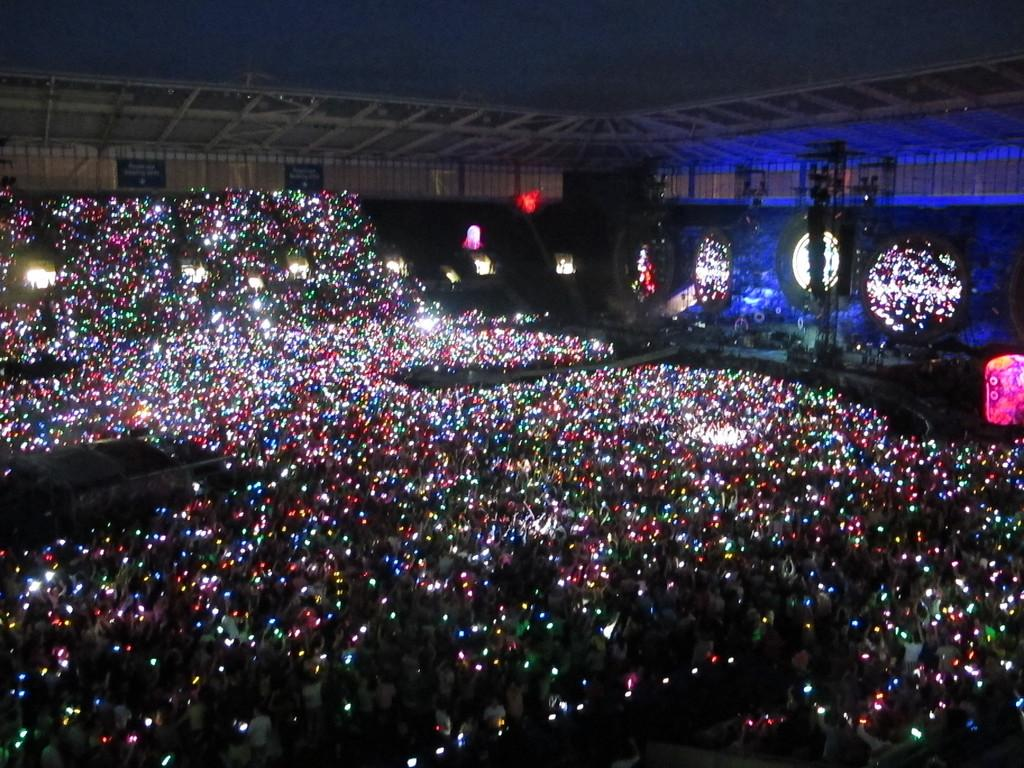How many people are present in the image? There are many people in the image. What are the people holding in their hands? The people are holding lights in their hands. What event is taking place in the image? It appears to be a concert. Where is the stage located in the image? The stage is on the right side of the image. What is above the stage? There is a ceiling above the stage. Reasoning: Let' Let's think step by step in order to produce the conversation. We start by identifying the main subject in the image, which is the large number of people. Then, we expand the conversation to include other details, such as the lights, the concert setting, and the stage and ceiling. Each question is designed to elicit a specific detail about the image that is known from the provided facts. Absurd Question/Answer: How many snakes can be seen slithering on the coast in the image? There are no snakes or coast visible in the image; it features a concert with people holding lights. What is the plot of the story being told in the image? There is no story being told in the image; it is a photograph of a concert. How many snakes can be seen slithering on the coast in the image? There are no snakes or coast visible in the image; it features a concert with people holding lights. What is the plot of the story being told in the image? There is no story being told in the image; it is a photograph of a concert. 